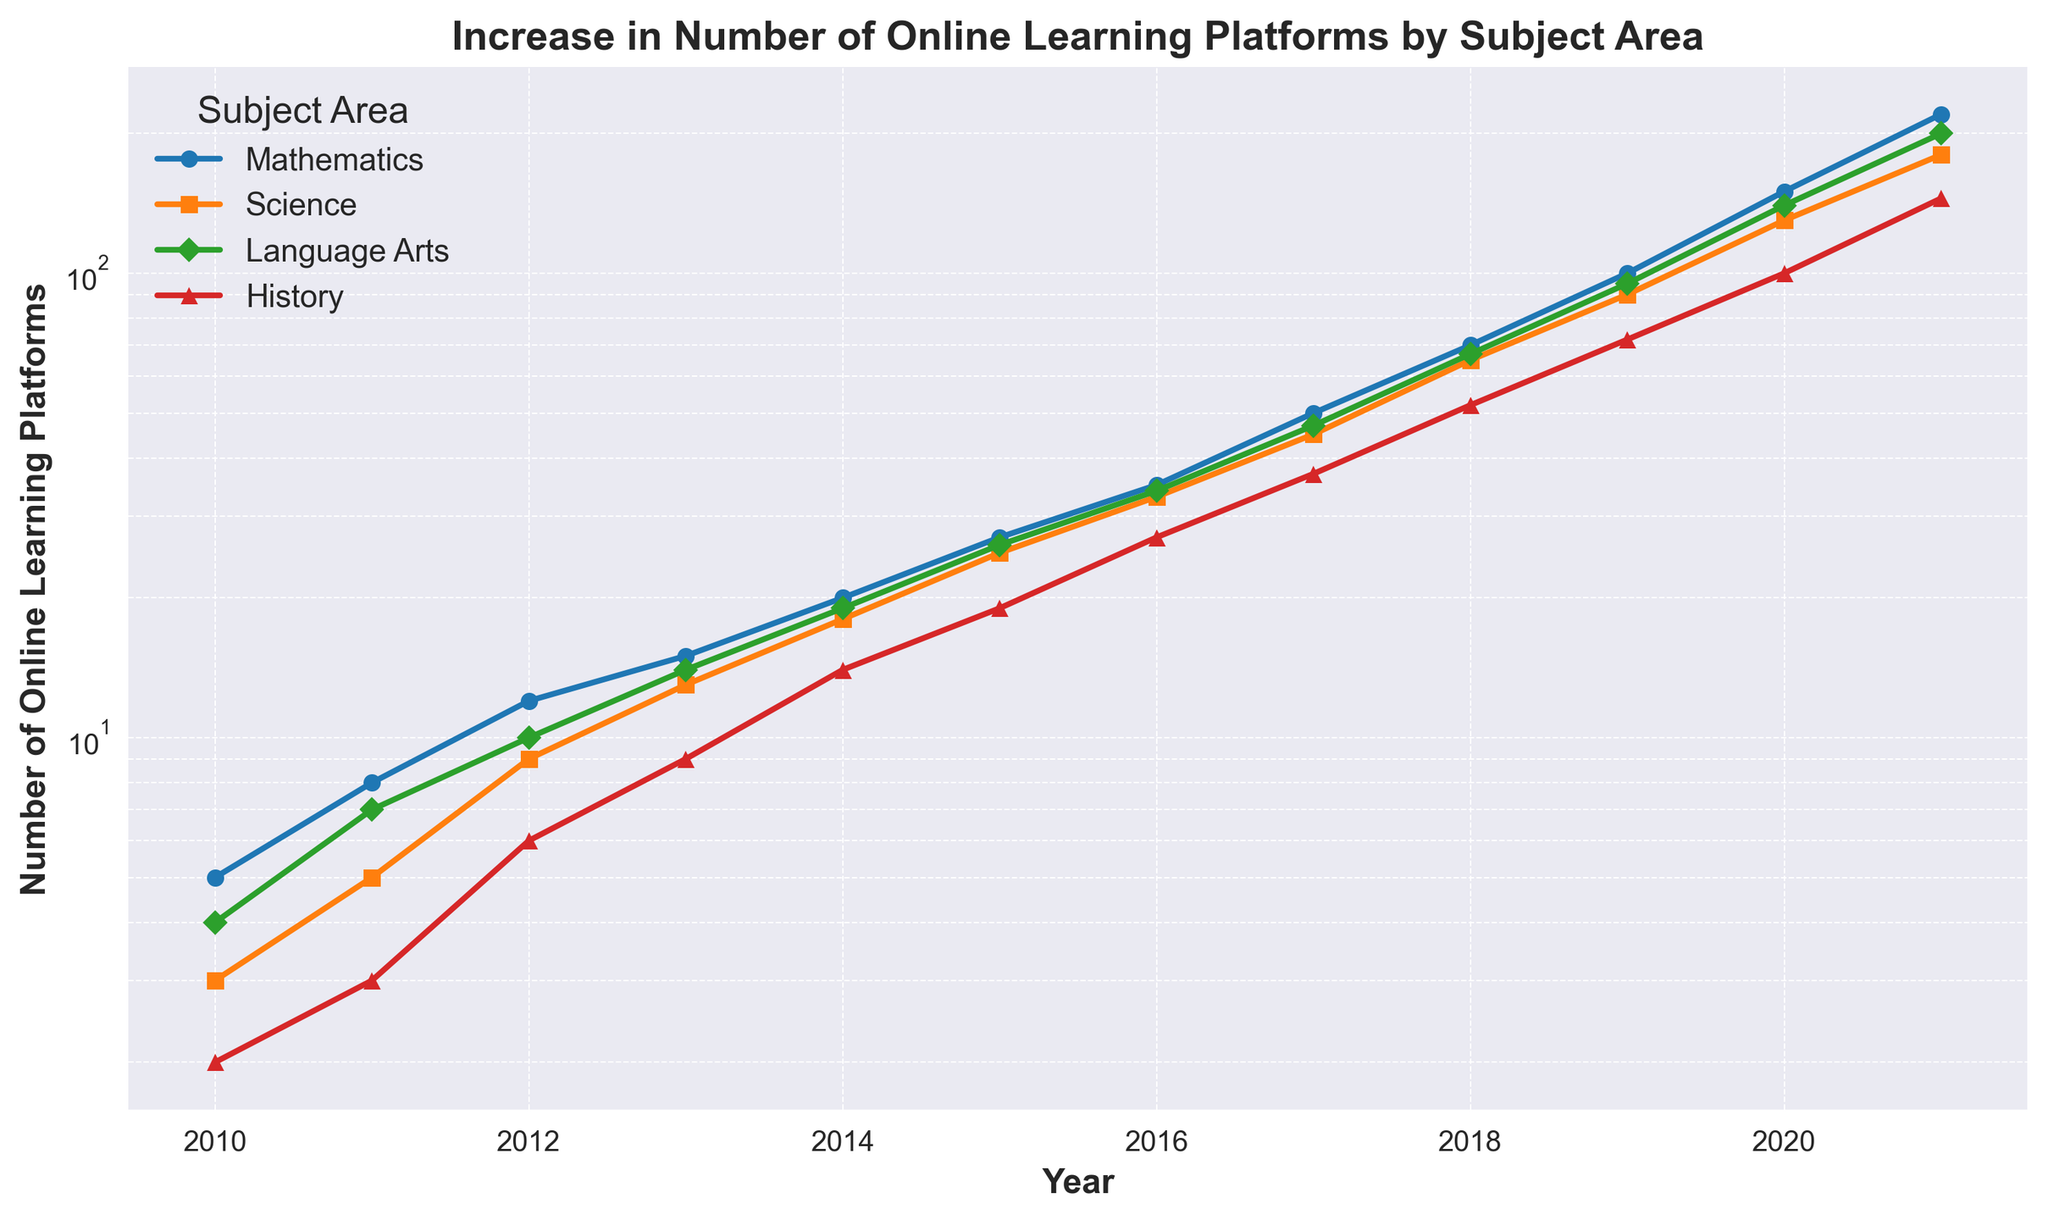Which subject area had the highest number of online learning platforms in 2021? Look at the endpoint for each subject area in 2021. The highest value is in the data series for Language Arts.
Answer: Language Arts Is the increase in online learning platforms from 2019 to 2020 greater for Mathematics or Science? Compare the differences between 2019 and 2020 for both subjects: Mathematics (150 - 100 = 50), Science (130 - 90 = 40). Therefore, the increase for Mathematics is greater.
Answer: Mathematics How many platforms were available for History in 2015? Locate the marker for History in the year 2015. The value is 19.
Answer: 19 What is the trend pattern for Mathematics between 2010 and 2021? Observe the logarithmic increase in the number of platforms for Mathematics from 5 in 2010 to 220 in 2021, showing an exponential growth pattern.
Answer: Exponential growth Between 2016 and 2018, which subject showed the largest percentage increase in platforms? Calculate the percentage increase: (2018-2016)/2016*100 for each subject. The largest percentage is seen in History: ((52-27)/27)*100 ≈ 92.59%.
Answer: History Did any subject have a year where the number of platforms decreased compared to the previous year? Examine each series for dips between consecutive years. There are no decreases in any subject areas; all values show year-over-year increases.
Answer: No Which subject saw the slowest growth in online learning platforms from 2010 to 2021? Compare the increase in values from 2010 to 2021 across all subjects. Science increased the fewest total platforms (180-3 = 177).
Answer: Science How did the growth in Language Arts platforms between 2014 and 2015 compare to its growth between 2019 and 2020? Calculate the differences: 2015-2014 (26-19 = 7) and 2020-2019 (140-95 = 45). The growth between 2019 and 2020 is much greater.
Answer: 2019 to 2020 What is the ratio of the number of platforms for Science to History in 2017? Find the values for both subjects in 2017: Science (45), History (37). The ratio is 45/37. Simplified, it remains 45:37.
Answer: 45:37 By how much did the number of platforms for History increase from 2012 to 2013? Subtract the value for 2012 from 2013 for History: 9 - 6 = 3.
Answer: 3 